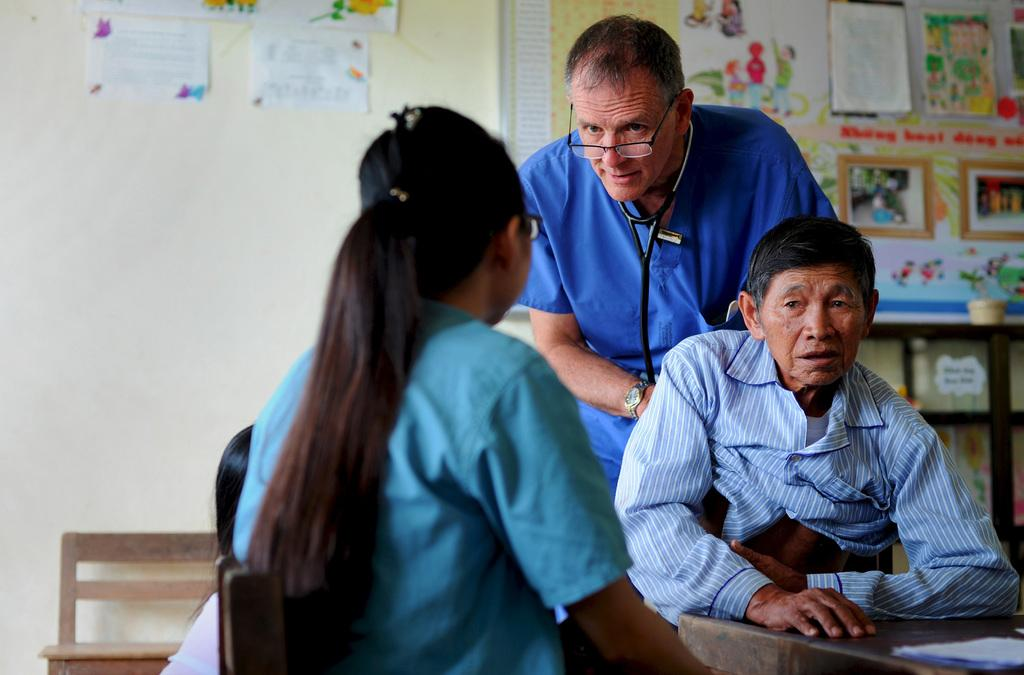What is the profession of the person in the image? There is a doctor in the image. Who is the doctor interacting with? The doctor is talking to a girl. What is the doctor doing in the image? The doctor is giving treatment to a man. Where is the lunchroom located in the image? There is no lunchroom present in the image. What grade is the girl in the image? The provided facts do not mention the girl's grade. 